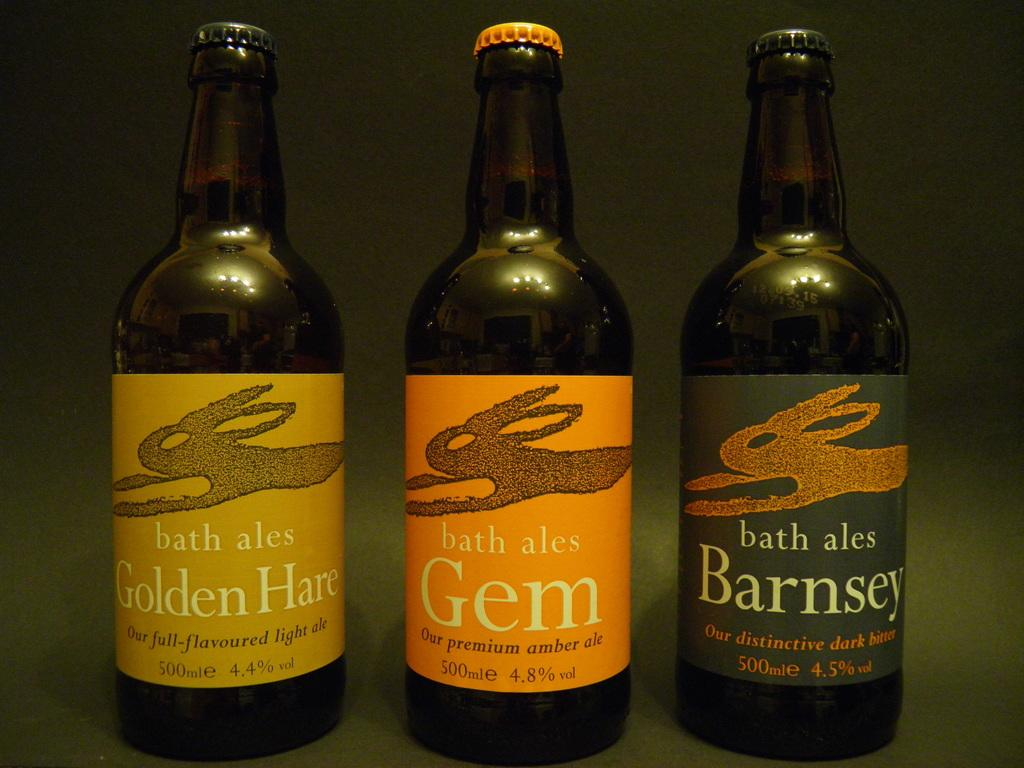<image>
Create a compact narrative representing the image presented. Three bottles of bath ales in full flavoured light ale, premium ale, and distinctive dark bitter. 